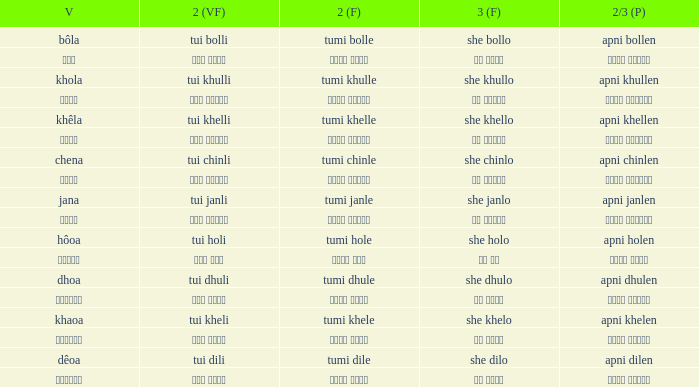What is the 2(vf) for তুমি বললে? তুই বললি. 